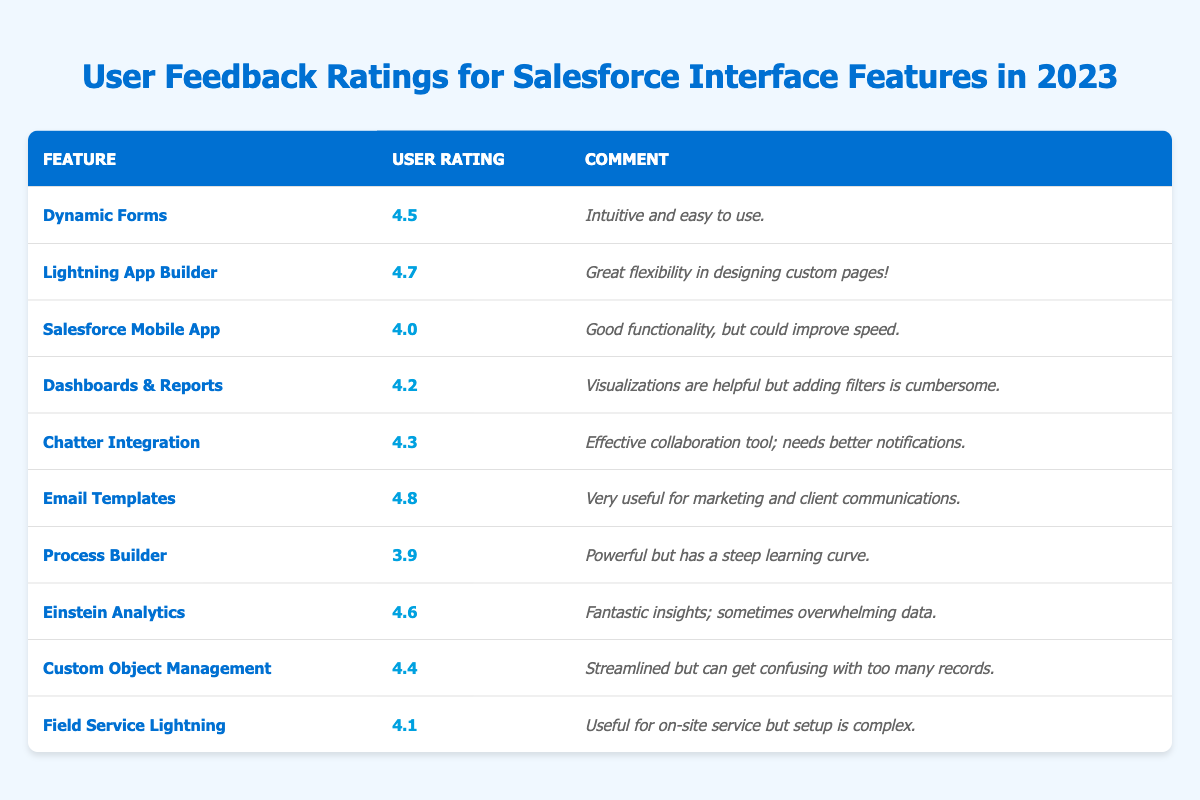What is the highest user rating for a feature? The table lists several features with their corresponding user ratings. The highest value in the "User Rating" column is 4.8, which corresponds to the "Email Templates" feature.
Answer: 4.8 Which feature has the lowest user rating? Looking at the "User Rating" column, the lowest value is 3.9, associated with the "Process Builder" feature.
Answer: Process Builder How many features have a user rating above 4.5? By examining the ratings, the features with ratings above 4.5 are "Lightning App Builder" (4.7), "Email Templates" (4.8), and "Einstein Analytics" (4.6). There are 3 such features.
Answer: 3 Is the comment associated with "Salesforce Mobile App" more positive than its rating? The "Salesforce Mobile App" has a rating of 4.0, and the comment suggests it has good functionality but could improve speed, indicating a mixed sentiment. Therefore, the comment is not more positive than its rating.
Answer: No What is the average user rating for all features listed? To calculate the average, sum all user ratings (4.5 + 4.7 + 4.0 + 4.2 + 4.3 + 4.8 + 3.9 + 4.6 + 4.4 + 4.1 = 44.5) and divide by the number of features (10). The average is 44.5 / 10 = 4.45.
Answer: 4.45 Which features require improvement based on their comments, and what are the common themes of feedback? The features that require improvement are "Salesforce Mobile App" (speed), "Dashboards & Reports" (filtering), "Chatter Integration" (notifications), "Process Builder" (learning curve), and "Field Service Lightning" (setup complexity). Common themes include functionality speed and user-friendliness.
Answer: Speed and usability issues Is it true that all features with ratings of 4.5 or higher received positive comments? A review of the comments for features rated 4.5 or higher indicates that while most comments are positive, "Einstein Analytics" mentions overwhelming data, which implies a negative aspect. Therefore, not all comments are entirely positive despite high ratings.
Answer: No What is the difference between the highest and lowest ratings? The highest rating is 4.8 (Email Templates) and the lowest is 3.9 (Process Builder). The difference is 4.8 - 3.9 = 0.9.
Answer: 0.9 Which feature has a user rating closest to the average calculated? Previously, the average user rating was calculated as 4.45. The features with ratings closest to this average are "Dynamic Forms" (4.5) and "Custom Object Management" (4.4), making both of them equally close.
Answer: Dynamic Forms and Custom Object Management What proportion of features rated 4.0 and above have comments that highlight some form of user issue? The features rated 4.0 and above are 8 in total: Dynamic Forms, Lightning App Builder, Salesforce Mobile App, Dashboards & Reports, Chatter Integration, Email Templates, Einstein Analytics, and Custom Object Management. Out of these, comments for Salesforce Mobile App, Dashboards & Reports, Chatter Integration, Process Builder (mentioned as lower), and Field Service Lightning indicate user issues, that means 5 have issues. Thus, the proportion is 5 out of 8, which simplifies to 0.625 or 62.5%.
Answer: 62.5% 